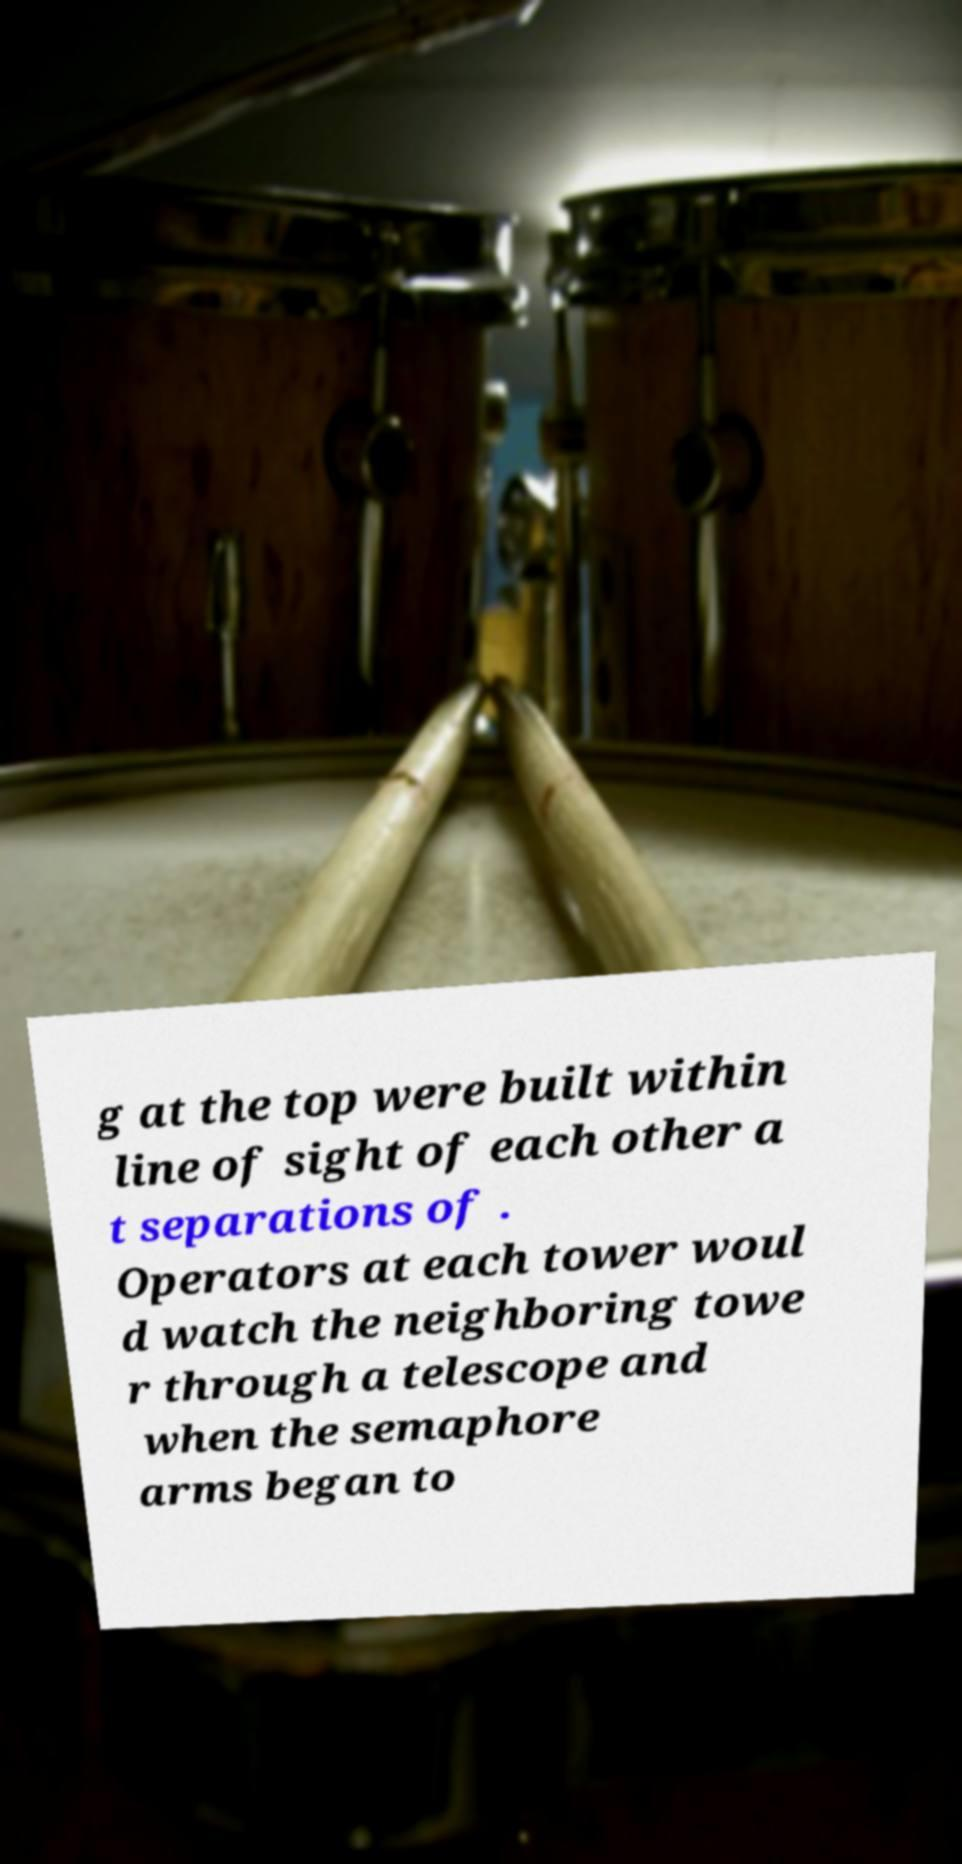Could you assist in decoding the text presented in this image and type it out clearly? g at the top were built within line of sight of each other a t separations of . Operators at each tower woul d watch the neighboring towe r through a telescope and when the semaphore arms began to 